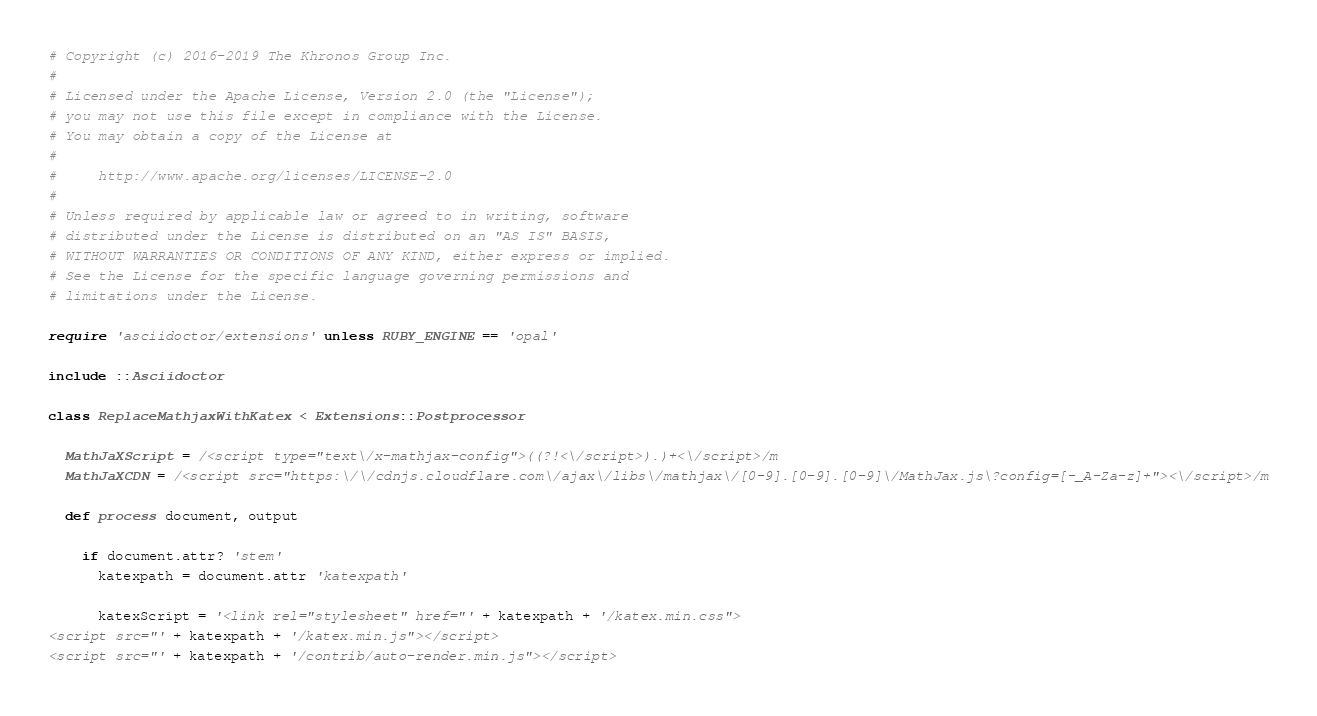Convert code to text. <code><loc_0><loc_0><loc_500><loc_500><_Ruby_># Copyright (c) 2016-2019 The Khronos Group Inc.
#
# Licensed under the Apache License, Version 2.0 (the "License");
# you may not use this file except in compliance with the License.
# You may obtain a copy of the License at
#
#     http://www.apache.org/licenses/LICENSE-2.0
#
# Unless required by applicable law or agreed to in writing, software
# distributed under the License is distributed on an "AS IS" BASIS,
# WITHOUT WARRANTIES OR CONDITIONS OF ANY KIND, either express or implied.
# See the License for the specific language governing permissions and
# limitations under the License.

require 'asciidoctor/extensions' unless RUBY_ENGINE == 'opal'

include ::Asciidoctor

class ReplaceMathjaxWithKatex < Extensions::Postprocessor

  MathJaXScript = /<script type="text\/x-mathjax-config">((?!<\/script>).)+<\/script>/m
  MathJaXCDN = /<script src="https:\/\/cdnjs.cloudflare.com\/ajax\/libs\/mathjax\/[0-9].[0-9].[0-9]\/MathJax.js\?config=[-_A-Za-z]+"><\/script>/m

  def process document, output

    if document.attr? 'stem'
      katexpath = document.attr 'katexpath'

      katexScript = '<link rel="stylesheet" href="' + katexpath + '/katex.min.css">
<script src="' + katexpath + '/katex.min.js"></script>
<script src="' + katexpath + '/contrib/auto-render.min.js"></script></code> 